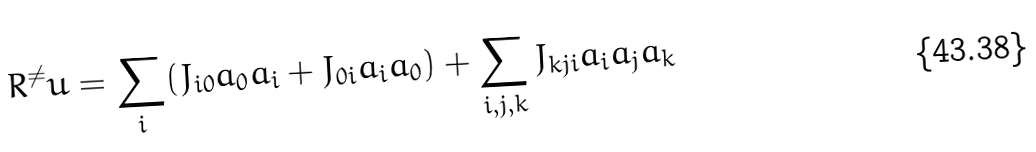<formula> <loc_0><loc_0><loc_500><loc_500>R ^ { \ne } u = \sum _ { i } ( J _ { i 0 } a _ { 0 } a _ { i } + J _ { 0 i } a _ { i } a _ { 0 } ) + \sum _ { i , j , k } J _ { k j i } a _ { i } a _ { j } a _ { k }</formula> 